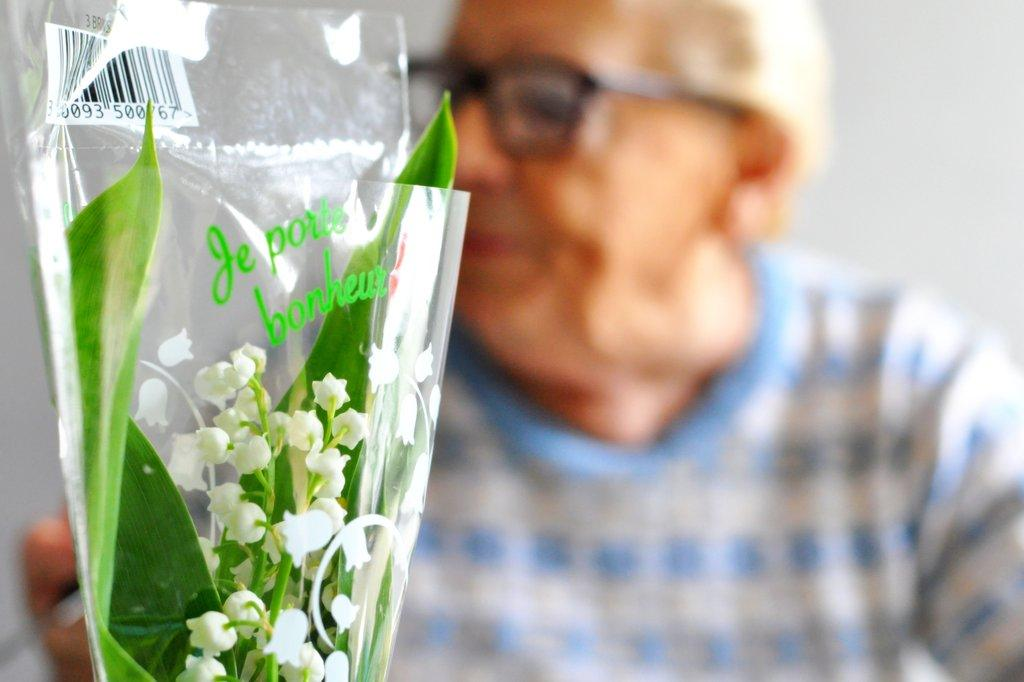Who is the main subject in the picture? There is an old man in the picture. What can be observed about the old man's appearance? The old man is wearing spectacles. What other object is present in the image? There is a flower bouquet in a transparent cover in the picture. What type of health issues is the old man experiencing in the image? There is no indication of any health issues in the image; the old man is simply wearing spectacles. 